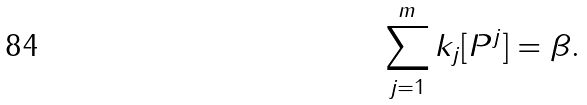<formula> <loc_0><loc_0><loc_500><loc_500>\sum _ { j = 1 } ^ { m } k _ { j } [ P ^ { j } ] = \beta .</formula> 